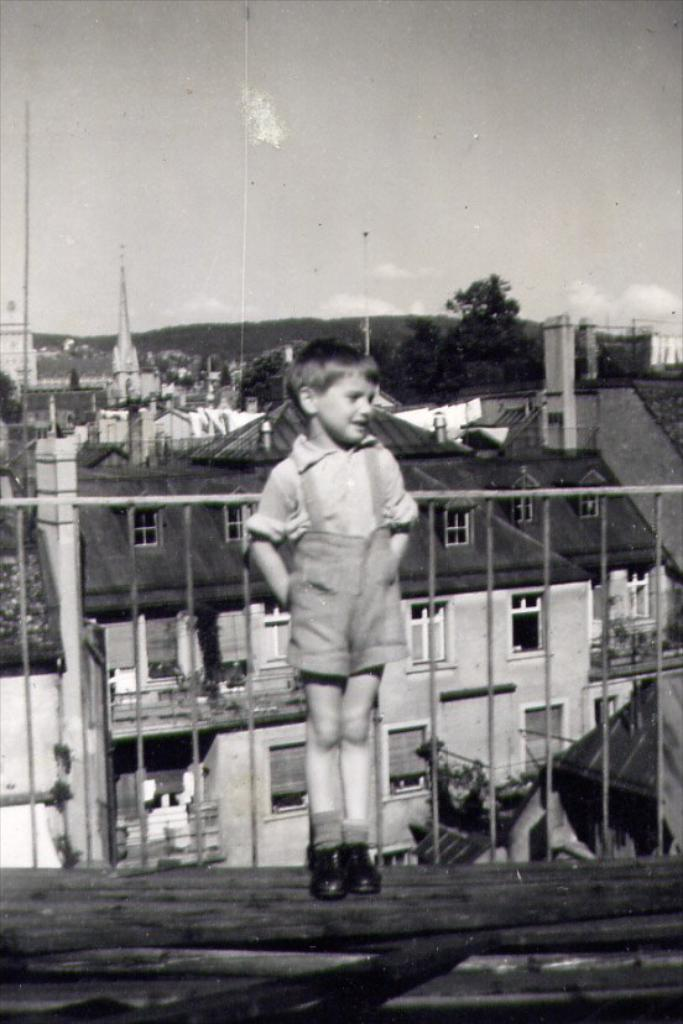What is the color scheme of the image? The image is black and white. What is the main subject in the image? There is a boy standing in the image. What is behind the boy in the image? There is a railing behind the boy. What can be seen in the background of the image? There are buildings, trees, and the sky visible in the background. What type of cheese is the boy holding in the image? There is no cheese present in the image. What kind of coach is the boy using to travel in the image? There is no coach present in the image. 